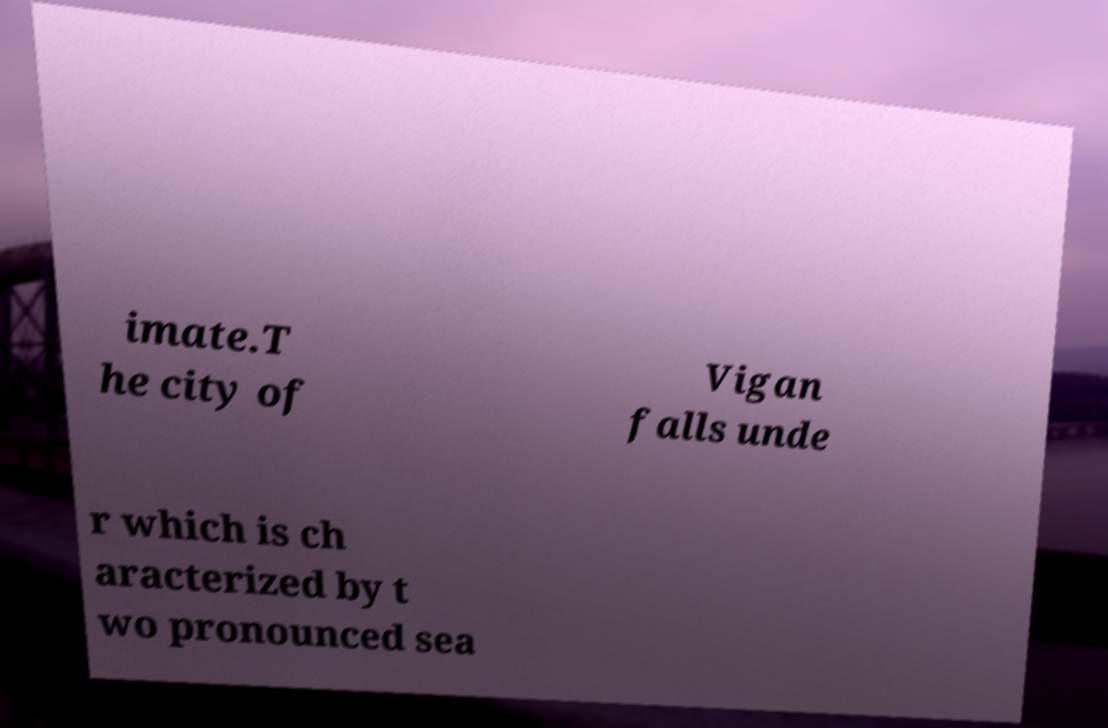Could you extract and type out the text from this image? imate.T he city of Vigan falls unde r which is ch aracterized by t wo pronounced sea 